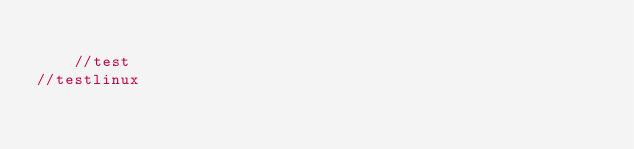Convert code to text. <code><loc_0><loc_0><loc_500><loc_500><_PHP_>
    //test
//testlinux</code> 